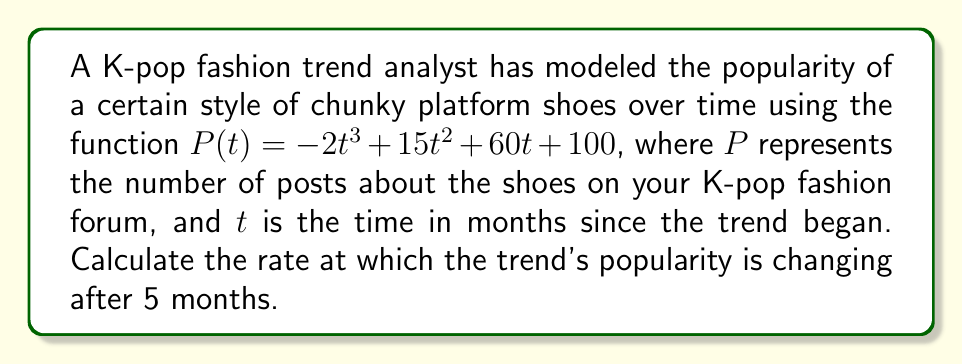What is the answer to this math problem? To solve this problem, we need to find the rate of change of the popularity function $P(t)$ at $t = 5$ months. This can be done by calculating the derivative of $P(t)$ and then evaluating it at $t = 5$.

Step 1: Find the derivative of $P(t)$
$$P(t) = -2t^3 + 15t^2 + 60t + 100$$
$$P'(t) = -6t^2 + 30t + 60$$

Step 2: Evaluate $P'(t)$ at $t = 5$
$$P'(5) = -6(5)^2 + 30(5) + 60$$
$$= -6(25) + 150 + 60$$
$$= -150 + 150 + 60$$
$$= 60$$

The rate of change is measured in posts per month, as $P$ represents the number of posts and $t$ represents time in months.
Answer: The rate at which the trend's popularity is changing after 5 months is 60 posts per month. 